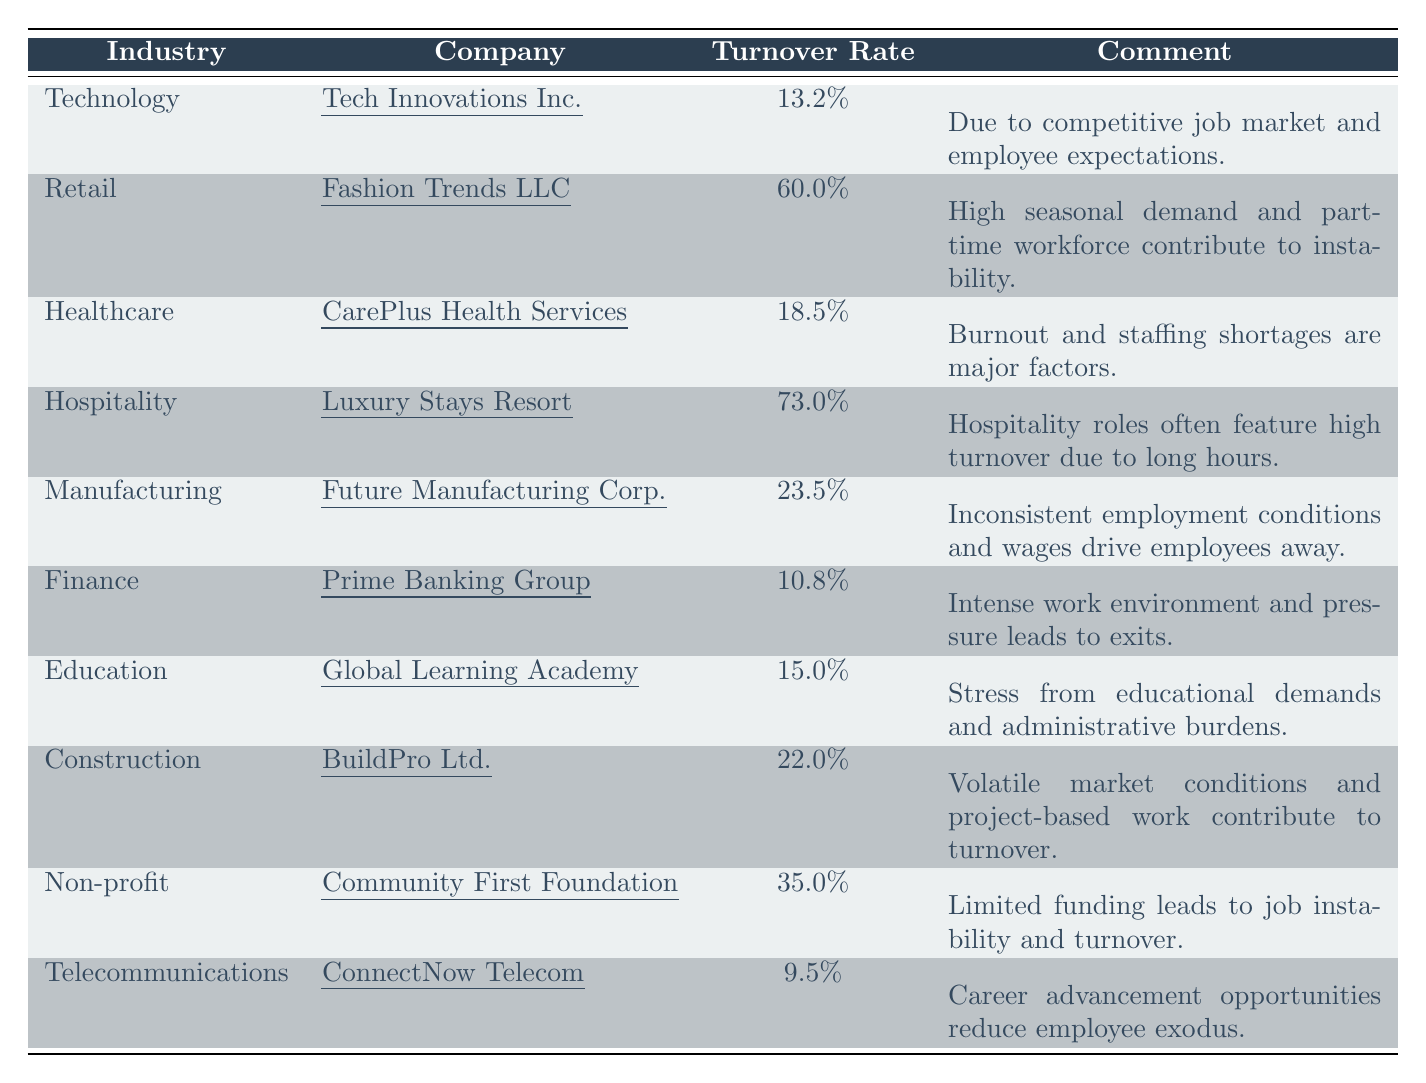What is the turnover rate for the Telecommunications industry? The table lists the turnover rate for Telecommunications as 9.5%.
Answer: 9.5% Which industry has the highest turnover rate? The table indicates that the Hospitality industry has the highest turnover rate at 73.0%.
Answer: 73.0% What is the turnover rate for Tech Innovations Inc.? According to the table, Tech Innovations Inc. has a turnover rate of 13.2%.
Answer: 13.2% Which companies have a turnover rate greater than 30%? By examining the table, the companies with a turnover rate greater than 30% are Fashion Trends LLC (60.0%) and Luxury Stays Resort (73.0%).
Answer: Fashion Trends LLC and Luxury Stays Resort Is the turnover rate for Finance lower than 15%? The table shows that the turnover rate for Finance is 10.8%, which is lower than 15%.
Answer: Yes What is the average turnover rate across all listed industries? To find the average, add all the turnover rates: (13.2 + 60 + 18.5 + 73 + 23.5 + 10.8 + 15 + 22 + 35 + 9.5) = 305.5. Then divide by the total number of industries (10): 305.5/10 = 30.55.
Answer: 30.55% What turnover rate is associated with the Non-profit sector? The Non-profit sector has a turnover rate of 35.0% as per the table.
Answer: 35.0% Which industries report burnout as a factor for employee turnover? The Healthcare industry cites burnout as a factor in their turnover, as mentioned in the table comments.
Answer: Healthcare How many industries have a turnover rate below 15%? The table indicates that there are three industries (Finance, Telecommunications, and Technology) with turnover rates below 15%.
Answer: 3 Which industry has the lowest turnover rate? The table specifies Telecommunications as having the lowest turnover rate at 9.5%.
Answer: 9.5% Are there any industries where long hours are mentioned as a contributing factor to turnover? Yes, the Hospitality industry mentions long hours as a factor contributing to its high turnover rate.
Answer: Yes 